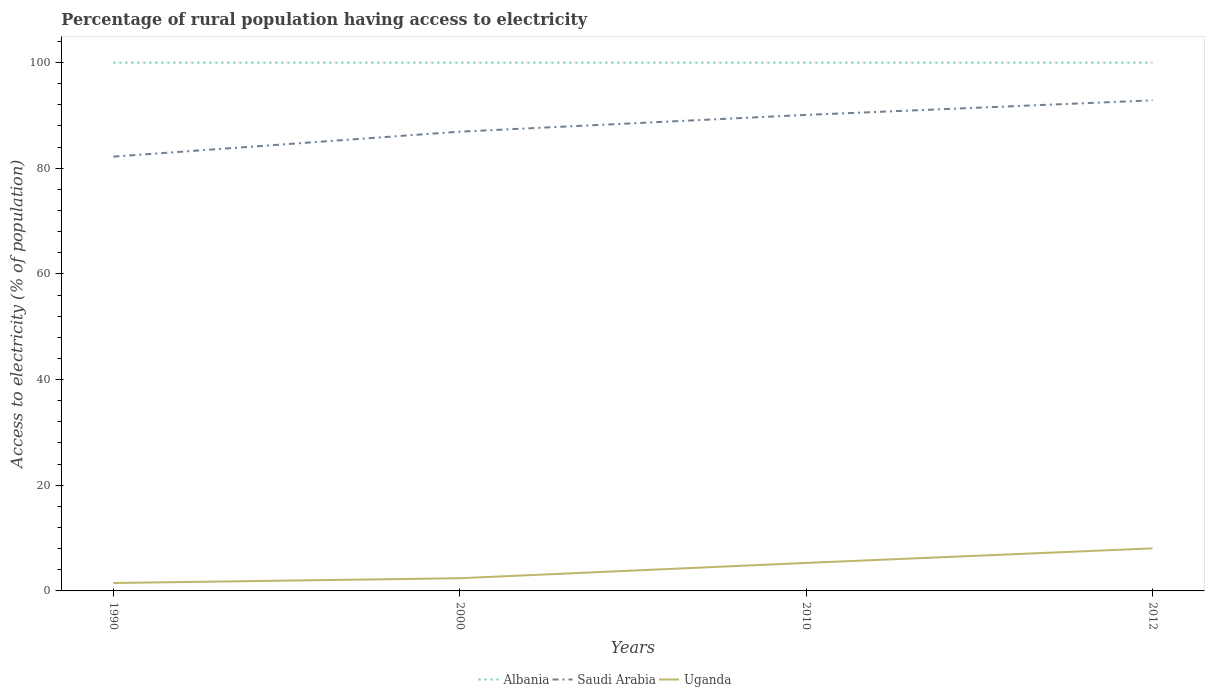How many different coloured lines are there?
Your response must be concise. 3. Does the line corresponding to Albania intersect with the line corresponding to Uganda?
Your response must be concise. No. Is the number of lines equal to the number of legend labels?
Your answer should be very brief. Yes. What is the total percentage of rural population having access to electricity in Albania in the graph?
Provide a succinct answer. 0. What is the difference between the highest and the second highest percentage of rural population having access to electricity in Saudi Arabia?
Provide a succinct answer. 10.65. How many years are there in the graph?
Your answer should be very brief. 4. What is the difference between two consecutive major ticks on the Y-axis?
Ensure brevity in your answer.  20. Are the values on the major ticks of Y-axis written in scientific E-notation?
Your response must be concise. No. Does the graph contain any zero values?
Provide a short and direct response. No. Where does the legend appear in the graph?
Your answer should be compact. Bottom center. What is the title of the graph?
Your response must be concise. Percentage of rural population having access to electricity. Does "Guinea" appear as one of the legend labels in the graph?
Make the answer very short. No. What is the label or title of the X-axis?
Provide a succinct answer. Years. What is the label or title of the Y-axis?
Give a very brief answer. Access to electricity (% of population). What is the Access to electricity (% of population) in Albania in 1990?
Offer a very short reply. 100. What is the Access to electricity (% of population) in Saudi Arabia in 1990?
Offer a terse response. 82.2. What is the Access to electricity (% of population) of Albania in 2000?
Provide a succinct answer. 100. What is the Access to electricity (% of population) of Saudi Arabia in 2000?
Provide a short and direct response. 86.93. What is the Access to electricity (% of population) of Saudi Arabia in 2010?
Your answer should be very brief. 90.1. What is the Access to electricity (% of population) in Albania in 2012?
Your response must be concise. 100. What is the Access to electricity (% of population) of Saudi Arabia in 2012?
Offer a terse response. 92.85. What is the Access to electricity (% of population) of Uganda in 2012?
Keep it short and to the point. 8.05. Across all years, what is the maximum Access to electricity (% of population) in Albania?
Your answer should be very brief. 100. Across all years, what is the maximum Access to electricity (% of population) of Saudi Arabia?
Your response must be concise. 92.85. Across all years, what is the maximum Access to electricity (% of population) of Uganda?
Keep it short and to the point. 8.05. Across all years, what is the minimum Access to electricity (% of population) in Albania?
Your answer should be compact. 100. Across all years, what is the minimum Access to electricity (% of population) of Saudi Arabia?
Give a very brief answer. 82.2. What is the total Access to electricity (% of population) of Albania in the graph?
Your answer should be very brief. 400. What is the total Access to electricity (% of population) of Saudi Arabia in the graph?
Your answer should be very brief. 352.08. What is the total Access to electricity (% of population) of Uganda in the graph?
Offer a very short reply. 17.25. What is the difference between the Access to electricity (% of population) of Albania in 1990 and that in 2000?
Provide a succinct answer. 0. What is the difference between the Access to electricity (% of population) in Saudi Arabia in 1990 and that in 2000?
Offer a very short reply. -4.72. What is the difference between the Access to electricity (% of population) in Uganda in 1990 and that in 2000?
Make the answer very short. -0.9. What is the difference between the Access to electricity (% of population) of Saudi Arabia in 1990 and that in 2010?
Make the answer very short. -7.9. What is the difference between the Access to electricity (% of population) of Albania in 1990 and that in 2012?
Provide a short and direct response. 0. What is the difference between the Access to electricity (% of population) of Saudi Arabia in 1990 and that in 2012?
Offer a terse response. -10.65. What is the difference between the Access to electricity (% of population) of Uganda in 1990 and that in 2012?
Your answer should be compact. -6.55. What is the difference between the Access to electricity (% of population) in Saudi Arabia in 2000 and that in 2010?
Make the answer very short. -3.17. What is the difference between the Access to electricity (% of population) in Uganda in 2000 and that in 2010?
Your answer should be very brief. -2.9. What is the difference between the Access to electricity (% of population) in Albania in 2000 and that in 2012?
Offer a terse response. 0. What is the difference between the Access to electricity (% of population) in Saudi Arabia in 2000 and that in 2012?
Your answer should be very brief. -5.93. What is the difference between the Access to electricity (% of population) of Uganda in 2000 and that in 2012?
Your answer should be very brief. -5.65. What is the difference between the Access to electricity (% of population) in Saudi Arabia in 2010 and that in 2012?
Ensure brevity in your answer.  -2.75. What is the difference between the Access to electricity (% of population) in Uganda in 2010 and that in 2012?
Your response must be concise. -2.75. What is the difference between the Access to electricity (% of population) in Albania in 1990 and the Access to electricity (% of population) in Saudi Arabia in 2000?
Offer a very short reply. 13.07. What is the difference between the Access to electricity (% of population) of Albania in 1990 and the Access to electricity (% of population) of Uganda in 2000?
Make the answer very short. 97.6. What is the difference between the Access to electricity (% of population) of Saudi Arabia in 1990 and the Access to electricity (% of population) of Uganda in 2000?
Your answer should be compact. 79.8. What is the difference between the Access to electricity (% of population) of Albania in 1990 and the Access to electricity (% of population) of Saudi Arabia in 2010?
Your answer should be very brief. 9.9. What is the difference between the Access to electricity (% of population) in Albania in 1990 and the Access to electricity (% of population) in Uganda in 2010?
Your response must be concise. 94.7. What is the difference between the Access to electricity (% of population) in Saudi Arabia in 1990 and the Access to electricity (% of population) in Uganda in 2010?
Offer a terse response. 76.9. What is the difference between the Access to electricity (% of population) in Albania in 1990 and the Access to electricity (% of population) in Saudi Arabia in 2012?
Offer a very short reply. 7.15. What is the difference between the Access to electricity (% of population) of Albania in 1990 and the Access to electricity (% of population) of Uganda in 2012?
Your answer should be compact. 91.95. What is the difference between the Access to electricity (% of population) in Saudi Arabia in 1990 and the Access to electricity (% of population) in Uganda in 2012?
Make the answer very short. 74.15. What is the difference between the Access to electricity (% of population) of Albania in 2000 and the Access to electricity (% of population) of Saudi Arabia in 2010?
Ensure brevity in your answer.  9.9. What is the difference between the Access to electricity (% of population) of Albania in 2000 and the Access to electricity (% of population) of Uganda in 2010?
Make the answer very short. 94.7. What is the difference between the Access to electricity (% of population) of Saudi Arabia in 2000 and the Access to electricity (% of population) of Uganda in 2010?
Ensure brevity in your answer.  81.63. What is the difference between the Access to electricity (% of population) of Albania in 2000 and the Access to electricity (% of population) of Saudi Arabia in 2012?
Your answer should be compact. 7.15. What is the difference between the Access to electricity (% of population) in Albania in 2000 and the Access to electricity (% of population) in Uganda in 2012?
Make the answer very short. 91.95. What is the difference between the Access to electricity (% of population) in Saudi Arabia in 2000 and the Access to electricity (% of population) in Uganda in 2012?
Provide a short and direct response. 78.87. What is the difference between the Access to electricity (% of population) of Albania in 2010 and the Access to electricity (% of population) of Saudi Arabia in 2012?
Provide a succinct answer. 7.15. What is the difference between the Access to electricity (% of population) of Albania in 2010 and the Access to electricity (% of population) of Uganda in 2012?
Your answer should be compact. 91.95. What is the difference between the Access to electricity (% of population) in Saudi Arabia in 2010 and the Access to electricity (% of population) in Uganda in 2012?
Your answer should be very brief. 82.05. What is the average Access to electricity (% of population) of Albania per year?
Your response must be concise. 100. What is the average Access to electricity (% of population) of Saudi Arabia per year?
Offer a terse response. 88.02. What is the average Access to electricity (% of population) in Uganda per year?
Your answer should be compact. 4.31. In the year 1990, what is the difference between the Access to electricity (% of population) in Albania and Access to electricity (% of population) in Saudi Arabia?
Your answer should be very brief. 17.8. In the year 1990, what is the difference between the Access to electricity (% of population) in Albania and Access to electricity (% of population) in Uganda?
Your answer should be very brief. 98.5. In the year 1990, what is the difference between the Access to electricity (% of population) in Saudi Arabia and Access to electricity (% of population) in Uganda?
Your response must be concise. 80.7. In the year 2000, what is the difference between the Access to electricity (% of population) of Albania and Access to electricity (% of population) of Saudi Arabia?
Your answer should be compact. 13.07. In the year 2000, what is the difference between the Access to electricity (% of population) in Albania and Access to electricity (% of population) in Uganda?
Give a very brief answer. 97.6. In the year 2000, what is the difference between the Access to electricity (% of population) in Saudi Arabia and Access to electricity (% of population) in Uganda?
Make the answer very short. 84.53. In the year 2010, what is the difference between the Access to electricity (% of population) in Albania and Access to electricity (% of population) in Saudi Arabia?
Offer a very short reply. 9.9. In the year 2010, what is the difference between the Access to electricity (% of population) of Albania and Access to electricity (% of population) of Uganda?
Keep it short and to the point. 94.7. In the year 2010, what is the difference between the Access to electricity (% of population) of Saudi Arabia and Access to electricity (% of population) of Uganda?
Offer a very short reply. 84.8. In the year 2012, what is the difference between the Access to electricity (% of population) in Albania and Access to electricity (% of population) in Saudi Arabia?
Keep it short and to the point. 7.15. In the year 2012, what is the difference between the Access to electricity (% of population) of Albania and Access to electricity (% of population) of Uganda?
Give a very brief answer. 91.95. In the year 2012, what is the difference between the Access to electricity (% of population) of Saudi Arabia and Access to electricity (% of population) of Uganda?
Give a very brief answer. 84.8. What is the ratio of the Access to electricity (% of population) of Saudi Arabia in 1990 to that in 2000?
Your answer should be very brief. 0.95. What is the ratio of the Access to electricity (% of population) of Uganda in 1990 to that in 2000?
Make the answer very short. 0.62. What is the ratio of the Access to electricity (% of population) in Albania in 1990 to that in 2010?
Your answer should be very brief. 1. What is the ratio of the Access to electricity (% of population) of Saudi Arabia in 1990 to that in 2010?
Provide a succinct answer. 0.91. What is the ratio of the Access to electricity (% of population) of Uganda in 1990 to that in 2010?
Your response must be concise. 0.28. What is the ratio of the Access to electricity (% of population) in Albania in 1990 to that in 2012?
Provide a short and direct response. 1. What is the ratio of the Access to electricity (% of population) of Saudi Arabia in 1990 to that in 2012?
Your answer should be very brief. 0.89. What is the ratio of the Access to electricity (% of population) of Uganda in 1990 to that in 2012?
Make the answer very short. 0.19. What is the ratio of the Access to electricity (% of population) of Albania in 2000 to that in 2010?
Ensure brevity in your answer.  1. What is the ratio of the Access to electricity (% of population) in Saudi Arabia in 2000 to that in 2010?
Keep it short and to the point. 0.96. What is the ratio of the Access to electricity (% of population) of Uganda in 2000 to that in 2010?
Your answer should be compact. 0.45. What is the ratio of the Access to electricity (% of population) in Saudi Arabia in 2000 to that in 2012?
Your answer should be compact. 0.94. What is the ratio of the Access to electricity (% of population) in Uganda in 2000 to that in 2012?
Make the answer very short. 0.3. What is the ratio of the Access to electricity (% of population) of Saudi Arabia in 2010 to that in 2012?
Give a very brief answer. 0.97. What is the ratio of the Access to electricity (% of population) in Uganda in 2010 to that in 2012?
Offer a very short reply. 0.66. What is the difference between the highest and the second highest Access to electricity (% of population) in Saudi Arabia?
Offer a terse response. 2.75. What is the difference between the highest and the second highest Access to electricity (% of population) of Uganda?
Offer a very short reply. 2.75. What is the difference between the highest and the lowest Access to electricity (% of population) of Saudi Arabia?
Your response must be concise. 10.65. What is the difference between the highest and the lowest Access to electricity (% of population) in Uganda?
Your answer should be compact. 6.55. 